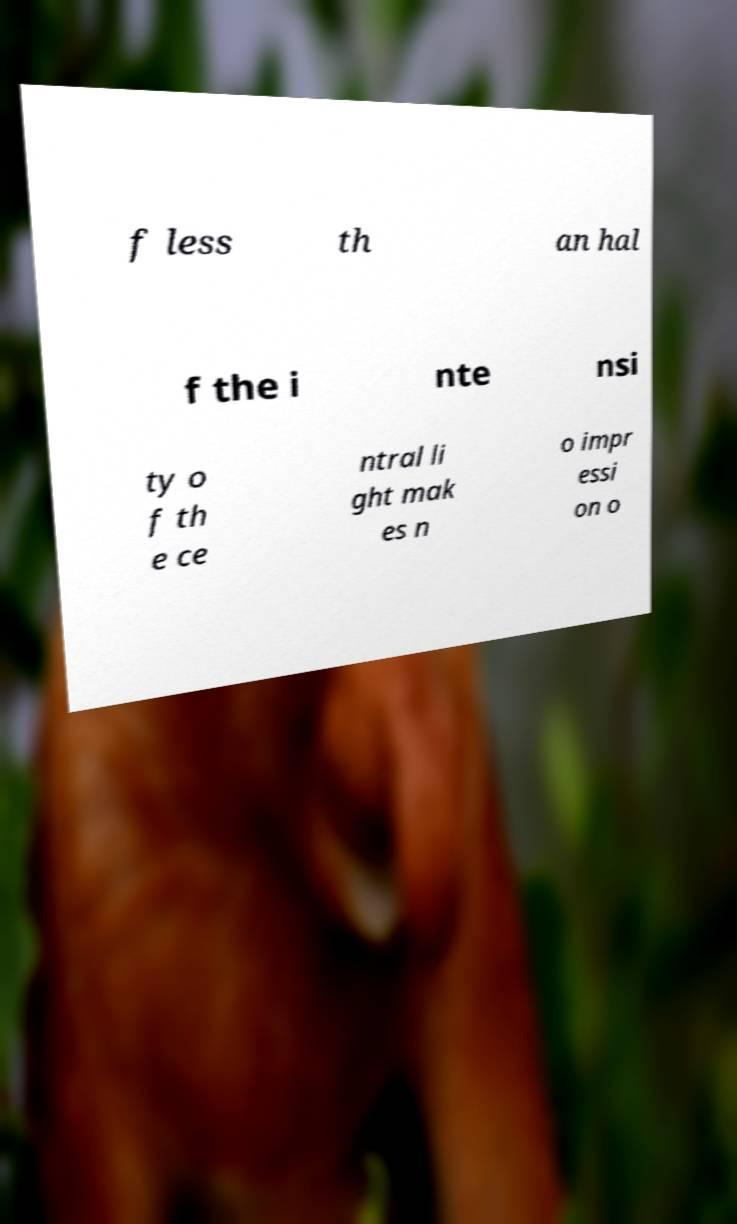Can you accurately transcribe the text from the provided image for me? f less th an hal f the i nte nsi ty o f th e ce ntral li ght mak es n o impr essi on o 